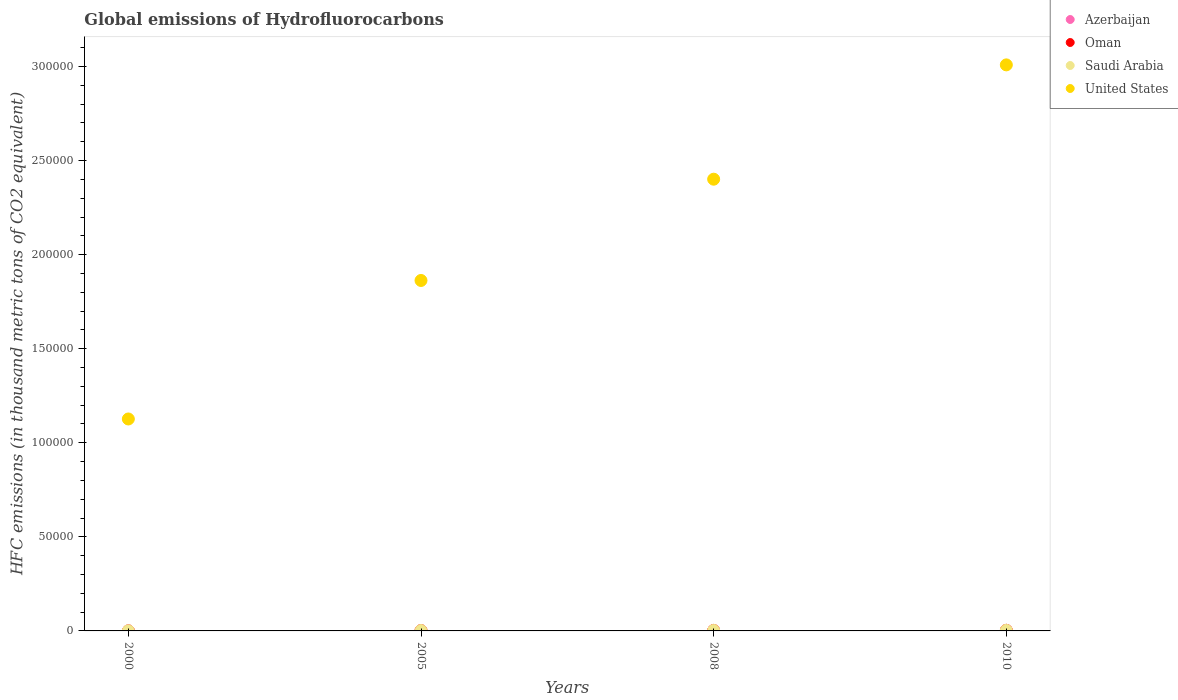How many different coloured dotlines are there?
Your response must be concise. 4. Is the number of dotlines equal to the number of legend labels?
Your answer should be very brief. Yes. What is the global emissions of Hydrofluorocarbons in Saudi Arabia in 2010?
Provide a succinct answer. 316. Across all years, what is the maximum global emissions of Hydrofluorocarbons in United States?
Offer a terse response. 3.01e+05. In which year was the global emissions of Hydrofluorocarbons in Oman maximum?
Your answer should be very brief. 2010. What is the total global emissions of Hydrofluorocarbons in Oman in the graph?
Provide a succinct answer. 781.1. What is the difference between the global emissions of Hydrofluorocarbons in United States in 2005 and that in 2010?
Your response must be concise. -1.15e+05. What is the difference between the global emissions of Hydrofluorocarbons in Oman in 2000 and the global emissions of Hydrofluorocarbons in Saudi Arabia in 2010?
Provide a succinct answer. -307.4. What is the average global emissions of Hydrofluorocarbons in Oman per year?
Your response must be concise. 195.27. In the year 2010, what is the difference between the global emissions of Hydrofluorocarbons in Saudi Arabia and global emissions of Hydrofluorocarbons in Azerbaijan?
Offer a terse response. 230. What is the ratio of the global emissions of Hydrofluorocarbons in Saudi Arabia in 2000 to that in 2010?
Your answer should be very brief. 0.24. Is the global emissions of Hydrofluorocarbons in Oman in 2000 less than that in 2010?
Give a very brief answer. Yes. What is the difference between the highest and the second highest global emissions of Hydrofluorocarbons in Saudi Arabia?
Give a very brief answer. 49.5. What is the difference between the highest and the lowest global emissions of Hydrofluorocarbons in Saudi Arabia?
Your answer should be very brief. 240.5. Is the sum of the global emissions of Hydrofluorocarbons in Oman in 2008 and 2010 greater than the maximum global emissions of Hydrofluorocarbons in United States across all years?
Make the answer very short. No. Is it the case that in every year, the sum of the global emissions of Hydrofluorocarbons in Oman and global emissions of Hydrofluorocarbons in Saudi Arabia  is greater than the sum of global emissions of Hydrofluorocarbons in Azerbaijan and global emissions of Hydrofluorocarbons in United States?
Provide a succinct answer. Yes. Is it the case that in every year, the sum of the global emissions of Hydrofluorocarbons in United States and global emissions of Hydrofluorocarbons in Saudi Arabia  is greater than the global emissions of Hydrofluorocarbons in Azerbaijan?
Give a very brief answer. Yes. What is the difference between two consecutive major ticks on the Y-axis?
Your response must be concise. 5.00e+04. Are the values on the major ticks of Y-axis written in scientific E-notation?
Your response must be concise. No. Does the graph contain grids?
Keep it short and to the point. No. Where does the legend appear in the graph?
Make the answer very short. Top right. How are the legend labels stacked?
Ensure brevity in your answer.  Vertical. What is the title of the graph?
Offer a very short reply. Global emissions of Hydrofluorocarbons. Does "East Asia (developing only)" appear as one of the legend labels in the graph?
Provide a succinct answer. No. What is the label or title of the Y-axis?
Your response must be concise. HFC emissions (in thousand metric tons of CO2 equivalent). What is the HFC emissions (in thousand metric tons of CO2 equivalent) of Oman in 2000?
Your answer should be very brief. 8.6. What is the HFC emissions (in thousand metric tons of CO2 equivalent) in Saudi Arabia in 2000?
Keep it short and to the point. 75.5. What is the HFC emissions (in thousand metric tons of CO2 equivalent) in United States in 2000?
Give a very brief answer. 1.13e+05. What is the HFC emissions (in thousand metric tons of CO2 equivalent) of Azerbaijan in 2005?
Offer a terse response. 55.4. What is the HFC emissions (in thousand metric tons of CO2 equivalent) of Oman in 2005?
Your answer should be compact. 173.6. What is the HFC emissions (in thousand metric tons of CO2 equivalent) in Saudi Arabia in 2005?
Offer a terse response. 196.9. What is the HFC emissions (in thousand metric tons of CO2 equivalent) in United States in 2005?
Your answer should be very brief. 1.86e+05. What is the HFC emissions (in thousand metric tons of CO2 equivalent) of Azerbaijan in 2008?
Make the answer very short. 73.1. What is the HFC emissions (in thousand metric tons of CO2 equivalent) of Oman in 2008?
Provide a succinct answer. 266.9. What is the HFC emissions (in thousand metric tons of CO2 equivalent) in Saudi Arabia in 2008?
Provide a succinct answer. 266.5. What is the HFC emissions (in thousand metric tons of CO2 equivalent) of United States in 2008?
Provide a succinct answer. 2.40e+05. What is the HFC emissions (in thousand metric tons of CO2 equivalent) in Azerbaijan in 2010?
Make the answer very short. 86. What is the HFC emissions (in thousand metric tons of CO2 equivalent) of Oman in 2010?
Your answer should be compact. 332. What is the HFC emissions (in thousand metric tons of CO2 equivalent) of Saudi Arabia in 2010?
Give a very brief answer. 316. What is the HFC emissions (in thousand metric tons of CO2 equivalent) in United States in 2010?
Offer a terse response. 3.01e+05. Across all years, what is the maximum HFC emissions (in thousand metric tons of CO2 equivalent) of Azerbaijan?
Provide a short and direct response. 86. Across all years, what is the maximum HFC emissions (in thousand metric tons of CO2 equivalent) in Oman?
Your answer should be very brief. 332. Across all years, what is the maximum HFC emissions (in thousand metric tons of CO2 equivalent) of Saudi Arabia?
Provide a short and direct response. 316. Across all years, what is the maximum HFC emissions (in thousand metric tons of CO2 equivalent) in United States?
Make the answer very short. 3.01e+05. Across all years, what is the minimum HFC emissions (in thousand metric tons of CO2 equivalent) of Oman?
Offer a terse response. 8.6. Across all years, what is the minimum HFC emissions (in thousand metric tons of CO2 equivalent) of Saudi Arabia?
Your answer should be compact. 75.5. Across all years, what is the minimum HFC emissions (in thousand metric tons of CO2 equivalent) of United States?
Offer a terse response. 1.13e+05. What is the total HFC emissions (in thousand metric tons of CO2 equivalent) in Azerbaijan in the graph?
Make the answer very short. 223. What is the total HFC emissions (in thousand metric tons of CO2 equivalent) of Oman in the graph?
Offer a very short reply. 781.1. What is the total HFC emissions (in thousand metric tons of CO2 equivalent) of Saudi Arabia in the graph?
Your answer should be very brief. 854.9. What is the total HFC emissions (in thousand metric tons of CO2 equivalent) of United States in the graph?
Provide a succinct answer. 8.40e+05. What is the difference between the HFC emissions (in thousand metric tons of CO2 equivalent) in Azerbaijan in 2000 and that in 2005?
Keep it short and to the point. -46.9. What is the difference between the HFC emissions (in thousand metric tons of CO2 equivalent) in Oman in 2000 and that in 2005?
Keep it short and to the point. -165. What is the difference between the HFC emissions (in thousand metric tons of CO2 equivalent) in Saudi Arabia in 2000 and that in 2005?
Offer a terse response. -121.4. What is the difference between the HFC emissions (in thousand metric tons of CO2 equivalent) of United States in 2000 and that in 2005?
Your response must be concise. -7.36e+04. What is the difference between the HFC emissions (in thousand metric tons of CO2 equivalent) of Azerbaijan in 2000 and that in 2008?
Offer a terse response. -64.6. What is the difference between the HFC emissions (in thousand metric tons of CO2 equivalent) of Oman in 2000 and that in 2008?
Provide a short and direct response. -258.3. What is the difference between the HFC emissions (in thousand metric tons of CO2 equivalent) in Saudi Arabia in 2000 and that in 2008?
Your response must be concise. -191. What is the difference between the HFC emissions (in thousand metric tons of CO2 equivalent) of United States in 2000 and that in 2008?
Your answer should be very brief. -1.27e+05. What is the difference between the HFC emissions (in thousand metric tons of CO2 equivalent) of Azerbaijan in 2000 and that in 2010?
Provide a succinct answer. -77.5. What is the difference between the HFC emissions (in thousand metric tons of CO2 equivalent) in Oman in 2000 and that in 2010?
Provide a succinct answer. -323.4. What is the difference between the HFC emissions (in thousand metric tons of CO2 equivalent) of Saudi Arabia in 2000 and that in 2010?
Make the answer very short. -240.5. What is the difference between the HFC emissions (in thousand metric tons of CO2 equivalent) in United States in 2000 and that in 2010?
Your answer should be very brief. -1.88e+05. What is the difference between the HFC emissions (in thousand metric tons of CO2 equivalent) in Azerbaijan in 2005 and that in 2008?
Offer a very short reply. -17.7. What is the difference between the HFC emissions (in thousand metric tons of CO2 equivalent) of Oman in 2005 and that in 2008?
Offer a very short reply. -93.3. What is the difference between the HFC emissions (in thousand metric tons of CO2 equivalent) of Saudi Arabia in 2005 and that in 2008?
Your answer should be compact. -69.6. What is the difference between the HFC emissions (in thousand metric tons of CO2 equivalent) of United States in 2005 and that in 2008?
Your response must be concise. -5.38e+04. What is the difference between the HFC emissions (in thousand metric tons of CO2 equivalent) of Azerbaijan in 2005 and that in 2010?
Offer a very short reply. -30.6. What is the difference between the HFC emissions (in thousand metric tons of CO2 equivalent) in Oman in 2005 and that in 2010?
Your answer should be very brief. -158.4. What is the difference between the HFC emissions (in thousand metric tons of CO2 equivalent) in Saudi Arabia in 2005 and that in 2010?
Provide a short and direct response. -119.1. What is the difference between the HFC emissions (in thousand metric tons of CO2 equivalent) in United States in 2005 and that in 2010?
Keep it short and to the point. -1.15e+05. What is the difference between the HFC emissions (in thousand metric tons of CO2 equivalent) of Oman in 2008 and that in 2010?
Keep it short and to the point. -65.1. What is the difference between the HFC emissions (in thousand metric tons of CO2 equivalent) of Saudi Arabia in 2008 and that in 2010?
Your answer should be compact. -49.5. What is the difference between the HFC emissions (in thousand metric tons of CO2 equivalent) in United States in 2008 and that in 2010?
Your answer should be very brief. -6.08e+04. What is the difference between the HFC emissions (in thousand metric tons of CO2 equivalent) in Azerbaijan in 2000 and the HFC emissions (in thousand metric tons of CO2 equivalent) in Oman in 2005?
Make the answer very short. -165.1. What is the difference between the HFC emissions (in thousand metric tons of CO2 equivalent) of Azerbaijan in 2000 and the HFC emissions (in thousand metric tons of CO2 equivalent) of Saudi Arabia in 2005?
Provide a succinct answer. -188.4. What is the difference between the HFC emissions (in thousand metric tons of CO2 equivalent) of Azerbaijan in 2000 and the HFC emissions (in thousand metric tons of CO2 equivalent) of United States in 2005?
Give a very brief answer. -1.86e+05. What is the difference between the HFC emissions (in thousand metric tons of CO2 equivalent) in Oman in 2000 and the HFC emissions (in thousand metric tons of CO2 equivalent) in Saudi Arabia in 2005?
Offer a terse response. -188.3. What is the difference between the HFC emissions (in thousand metric tons of CO2 equivalent) in Oman in 2000 and the HFC emissions (in thousand metric tons of CO2 equivalent) in United States in 2005?
Make the answer very short. -1.86e+05. What is the difference between the HFC emissions (in thousand metric tons of CO2 equivalent) of Saudi Arabia in 2000 and the HFC emissions (in thousand metric tons of CO2 equivalent) of United States in 2005?
Offer a very short reply. -1.86e+05. What is the difference between the HFC emissions (in thousand metric tons of CO2 equivalent) in Azerbaijan in 2000 and the HFC emissions (in thousand metric tons of CO2 equivalent) in Oman in 2008?
Your answer should be very brief. -258.4. What is the difference between the HFC emissions (in thousand metric tons of CO2 equivalent) in Azerbaijan in 2000 and the HFC emissions (in thousand metric tons of CO2 equivalent) in Saudi Arabia in 2008?
Your answer should be very brief. -258. What is the difference between the HFC emissions (in thousand metric tons of CO2 equivalent) in Azerbaijan in 2000 and the HFC emissions (in thousand metric tons of CO2 equivalent) in United States in 2008?
Provide a short and direct response. -2.40e+05. What is the difference between the HFC emissions (in thousand metric tons of CO2 equivalent) in Oman in 2000 and the HFC emissions (in thousand metric tons of CO2 equivalent) in Saudi Arabia in 2008?
Keep it short and to the point. -257.9. What is the difference between the HFC emissions (in thousand metric tons of CO2 equivalent) of Oman in 2000 and the HFC emissions (in thousand metric tons of CO2 equivalent) of United States in 2008?
Make the answer very short. -2.40e+05. What is the difference between the HFC emissions (in thousand metric tons of CO2 equivalent) of Saudi Arabia in 2000 and the HFC emissions (in thousand metric tons of CO2 equivalent) of United States in 2008?
Provide a short and direct response. -2.40e+05. What is the difference between the HFC emissions (in thousand metric tons of CO2 equivalent) of Azerbaijan in 2000 and the HFC emissions (in thousand metric tons of CO2 equivalent) of Oman in 2010?
Give a very brief answer. -323.5. What is the difference between the HFC emissions (in thousand metric tons of CO2 equivalent) in Azerbaijan in 2000 and the HFC emissions (in thousand metric tons of CO2 equivalent) in Saudi Arabia in 2010?
Keep it short and to the point. -307.5. What is the difference between the HFC emissions (in thousand metric tons of CO2 equivalent) in Azerbaijan in 2000 and the HFC emissions (in thousand metric tons of CO2 equivalent) in United States in 2010?
Your answer should be very brief. -3.01e+05. What is the difference between the HFC emissions (in thousand metric tons of CO2 equivalent) in Oman in 2000 and the HFC emissions (in thousand metric tons of CO2 equivalent) in Saudi Arabia in 2010?
Offer a very short reply. -307.4. What is the difference between the HFC emissions (in thousand metric tons of CO2 equivalent) of Oman in 2000 and the HFC emissions (in thousand metric tons of CO2 equivalent) of United States in 2010?
Give a very brief answer. -3.01e+05. What is the difference between the HFC emissions (in thousand metric tons of CO2 equivalent) in Saudi Arabia in 2000 and the HFC emissions (in thousand metric tons of CO2 equivalent) in United States in 2010?
Provide a succinct answer. -3.01e+05. What is the difference between the HFC emissions (in thousand metric tons of CO2 equivalent) in Azerbaijan in 2005 and the HFC emissions (in thousand metric tons of CO2 equivalent) in Oman in 2008?
Ensure brevity in your answer.  -211.5. What is the difference between the HFC emissions (in thousand metric tons of CO2 equivalent) of Azerbaijan in 2005 and the HFC emissions (in thousand metric tons of CO2 equivalent) of Saudi Arabia in 2008?
Keep it short and to the point. -211.1. What is the difference between the HFC emissions (in thousand metric tons of CO2 equivalent) of Azerbaijan in 2005 and the HFC emissions (in thousand metric tons of CO2 equivalent) of United States in 2008?
Offer a terse response. -2.40e+05. What is the difference between the HFC emissions (in thousand metric tons of CO2 equivalent) of Oman in 2005 and the HFC emissions (in thousand metric tons of CO2 equivalent) of Saudi Arabia in 2008?
Provide a short and direct response. -92.9. What is the difference between the HFC emissions (in thousand metric tons of CO2 equivalent) in Oman in 2005 and the HFC emissions (in thousand metric tons of CO2 equivalent) in United States in 2008?
Provide a succinct answer. -2.40e+05. What is the difference between the HFC emissions (in thousand metric tons of CO2 equivalent) in Saudi Arabia in 2005 and the HFC emissions (in thousand metric tons of CO2 equivalent) in United States in 2008?
Your answer should be very brief. -2.40e+05. What is the difference between the HFC emissions (in thousand metric tons of CO2 equivalent) of Azerbaijan in 2005 and the HFC emissions (in thousand metric tons of CO2 equivalent) of Oman in 2010?
Ensure brevity in your answer.  -276.6. What is the difference between the HFC emissions (in thousand metric tons of CO2 equivalent) of Azerbaijan in 2005 and the HFC emissions (in thousand metric tons of CO2 equivalent) of Saudi Arabia in 2010?
Ensure brevity in your answer.  -260.6. What is the difference between the HFC emissions (in thousand metric tons of CO2 equivalent) of Azerbaijan in 2005 and the HFC emissions (in thousand metric tons of CO2 equivalent) of United States in 2010?
Your answer should be very brief. -3.01e+05. What is the difference between the HFC emissions (in thousand metric tons of CO2 equivalent) in Oman in 2005 and the HFC emissions (in thousand metric tons of CO2 equivalent) in Saudi Arabia in 2010?
Keep it short and to the point. -142.4. What is the difference between the HFC emissions (in thousand metric tons of CO2 equivalent) of Oman in 2005 and the HFC emissions (in thousand metric tons of CO2 equivalent) of United States in 2010?
Keep it short and to the point. -3.01e+05. What is the difference between the HFC emissions (in thousand metric tons of CO2 equivalent) in Saudi Arabia in 2005 and the HFC emissions (in thousand metric tons of CO2 equivalent) in United States in 2010?
Provide a succinct answer. -3.01e+05. What is the difference between the HFC emissions (in thousand metric tons of CO2 equivalent) of Azerbaijan in 2008 and the HFC emissions (in thousand metric tons of CO2 equivalent) of Oman in 2010?
Make the answer very short. -258.9. What is the difference between the HFC emissions (in thousand metric tons of CO2 equivalent) of Azerbaijan in 2008 and the HFC emissions (in thousand metric tons of CO2 equivalent) of Saudi Arabia in 2010?
Your answer should be compact. -242.9. What is the difference between the HFC emissions (in thousand metric tons of CO2 equivalent) in Azerbaijan in 2008 and the HFC emissions (in thousand metric tons of CO2 equivalent) in United States in 2010?
Make the answer very short. -3.01e+05. What is the difference between the HFC emissions (in thousand metric tons of CO2 equivalent) of Oman in 2008 and the HFC emissions (in thousand metric tons of CO2 equivalent) of Saudi Arabia in 2010?
Your answer should be very brief. -49.1. What is the difference between the HFC emissions (in thousand metric tons of CO2 equivalent) in Oman in 2008 and the HFC emissions (in thousand metric tons of CO2 equivalent) in United States in 2010?
Ensure brevity in your answer.  -3.01e+05. What is the difference between the HFC emissions (in thousand metric tons of CO2 equivalent) of Saudi Arabia in 2008 and the HFC emissions (in thousand metric tons of CO2 equivalent) of United States in 2010?
Make the answer very short. -3.01e+05. What is the average HFC emissions (in thousand metric tons of CO2 equivalent) in Azerbaijan per year?
Make the answer very short. 55.75. What is the average HFC emissions (in thousand metric tons of CO2 equivalent) of Oman per year?
Give a very brief answer. 195.28. What is the average HFC emissions (in thousand metric tons of CO2 equivalent) in Saudi Arabia per year?
Give a very brief answer. 213.72. What is the average HFC emissions (in thousand metric tons of CO2 equivalent) of United States per year?
Offer a terse response. 2.10e+05. In the year 2000, what is the difference between the HFC emissions (in thousand metric tons of CO2 equivalent) of Azerbaijan and HFC emissions (in thousand metric tons of CO2 equivalent) of Oman?
Your answer should be very brief. -0.1. In the year 2000, what is the difference between the HFC emissions (in thousand metric tons of CO2 equivalent) in Azerbaijan and HFC emissions (in thousand metric tons of CO2 equivalent) in Saudi Arabia?
Your answer should be compact. -67. In the year 2000, what is the difference between the HFC emissions (in thousand metric tons of CO2 equivalent) in Azerbaijan and HFC emissions (in thousand metric tons of CO2 equivalent) in United States?
Offer a terse response. -1.13e+05. In the year 2000, what is the difference between the HFC emissions (in thousand metric tons of CO2 equivalent) in Oman and HFC emissions (in thousand metric tons of CO2 equivalent) in Saudi Arabia?
Your response must be concise. -66.9. In the year 2000, what is the difference between the HFC emissions (in thousand metric tons of CO2 equivalent) in Oman and HFC emissions (in thousand metric tons of CO2 equivalent) in United States?
Ensure brevity in your answer.  -1.13e+05. In the year 2000, what is the difference between the HFC emissions (in thousand metric tons of CO2 equivalent) of Saudi Arabia and HFC emissions (in thousand metric tons of CO2 equivalent) of United States?
Offer a terse response. -1.13e+05. In the year 2005, what is the difference between the HFC emissions (in thousand metric tons of CO2 equivalent) of Azerbaijan and HFC emissions (in thousand metric tons of CO2 equivalent) of Oman?
Provide a succinct answer. -118.2. In the year 2005, what is the difference between the HFC emissions (in thousand metric tons of CO2 equivalent) of Azerbaijan and HFC emissions (in thousand metric tons of CO2 equivalent) of Saudi Arabia?
Your response must be concise. -141.5. In the year 2005, what is the difference between the HFC emissions (in thousand metric tons of CO2 equivalent) of Azerbaijan and HFC emissions (in thousand metric tons of CO2 equivalent) of United States?
Your answer should be compact. -1.86e+05. In the year 2005, what is the difference between the HFC emissions (in thousand metric tons of CO2 equivalent) of Oman and HFC emissions (in thousand metric tons of CO2 equivalent) of Saudi Arabia?
Provide a short and direct response. -23.3. In the year 2005, what is the difference between the HFC emissions (in thousand metric tons of CO2 equivalent) of Oman and HFC emissions (in thousand metric tons of CO2 equivalent) of United States?
Provide a succinct answer. -1.86e+05. In the year 2005, what is the difference between the HFC emissions (in thousand metric tons of CO2 equivalent) of Saudi Arabia and HFC emissions (in thousand metric tons of CO2 equivalent) of United States?
Provide a short and direct response. -1.86e+05. In the year 2008, what is the difference between the HFC emissions (in thousand metric tons of CO2 equivalent) in Azerbaijan and HFC emissions (in thousand metric tons of CO2 equivalent) in Oman?
Offer a terse response. -193.8. In the year 2008, what is the difference between the HFC emissions (in thousand metric tons of CO2 equivalent) of Azerbaijan and HFC emissions (in thousand metric tons of CO2 equivalent) of Saudi Arabia?
Your answer should be very brief. -193.4. In the year 2008, what is the difference between the HFC emissions (in thousand metric tons of CO2 equivalent) of Azerbaijan and HFC emissions (in thousand metric tons of CO2 equivalent) of United States?
Offer a terse response. -2.40e+05. In the year 2008, what is the difference between the HFC emissions (in thousand metric tons of CO2 equivalent) of Oman and HFC emissions (in thousand metric tons of CO2 equivalent) of United States?
Provide a succinct answer. -2.40e+05. In the year 2008, what is the difference between the HFC emissions (in thousand metric tons of CO2 equivalent) in Saudi Arabia and HFC emissions (in thousand metric tons of CO2 equivalent) in United States?
Give a very brief answer. -2.40e+05. In the year 2010, what is the difference between the HFC emissions (in thousand metric tons of CO2 equivalent) in Azerbaijan and HFC emissions (in thousand metric tons of CO2 equivalent) in Oman?
Ensure brevity in your answer.  -246. In the year 2010, what is the difference between the HFC emissions (in thousand metric tons of CO2 equivalent) of Azerbaijan and HFC emissions (in thousand metric tons of CO2 equivalent) of Saudi Arabia?
Make the answer very short. -230. In the year 2010, what is the difference between the HFC emissions (in thousand metric tons of CO2 equivalent) of Azerbaijan and HFC emissions (in thousand metric tons of CO2 equivalent) of United States?
Provide a short and direct response. -3.01e+05. In the year 2010, what is the difference between the HFC emissions (in thousand metric tons of CO2 equivalent) in Oman and HFC emissions (in thousand metric tons of CO2 equivalent) in Saudi Arabia?
Your answer should be compact. 16. In the year 2010, what is the difference between the HFC emissions (in thousand metric tons of CO2 equivalent) in Oman and HFC emissions (in thousand metric tons of CO2 equivalent) in United States?
Your response must be concise. -3.01e+05. In the year 2010, what is the difference between the HFC emissions (in thousand metric tons of CO2 equivalent) of Saudi Arabia and HFC emissions (in thousand metric tons of CO2 equivalent) of United States?
Make the answer very short. -3.01e+05. What is the ratio of the HFC emissions (in thousand metric tons of CO2 equivalent) in Azerbaijan in 2000 to that in 2005?
Offer a terse response. 0.15. What is the ratio of the HFC emissions (in thousand metric tons of CO2 equivalent) in Oman in 2000 to that in 2005?
Your answer should be very brief. 0.05. What is the ratio of the HFC emissions (in thousand metric tons of CO2 equivalent) of Saudi Arabia in 2000 to that in 2005?
Your answer should be very brief. 0.38. What is the ratio of the HFC emissions (in thousand metric tons of CO2 equivalent) in United States in 2000 to that in 2005?
Provide a short and direct response. 0.6. What is the ratio of the HFC emissions (in thousand metric tons of CO2 equivalent) of Azerbaijan in 2000 to that in 2008?
Provide a short and direct response. 0.12. What is the ratio of the HFC emissions (in thousand metric tons of CO2 equivalent) of Oman in 2000 to that in 2008?
Your answer should be compact. 0.03. What is the ratio of the HFC emissions (in thousand metric tons of CO2 equivalent) in Saudi Arabia in 2000 to that in 2008?
Your answer should be compact. 0.28. What is the ratio of the HFC emissions (in thousand metric tons of CO2 equivalent) in United States in 2000 to that in 2008?
Your response must be concise. 0.47. What is the ratio of the HFC emissions (in thousand metric tons of CO2 equivalent) of Azerbaijan in 2000 to that in 2010?
Ensure brevity in your answer.  0.1. What is the ratio of the HFC emissions (in thousand metric tons of CO2 equivalent) in Oman in 2000 to that in 2010?
Offer a terse response. 0.03. What is the ratio of the HFC emissions (in thousand metric tons of CO2 equivalent) in Saudi Arabia in 2000 to that in 2010?
Your response must be concise. 0.24. What is the ratio of the HFC emissions (in thousand metric tons of CO2 equivalent) of United States in 2000 to that in 2010?
Your answer should be compact. 0.37. What is the ratio of the HFC emissions (in thousand metric tons of CO2 equivalent) of Azerbaijan in 2005 to that in 2008?
Your response must be concise. 0.76. What is the ratio of the HFC emissions (in thousand metric tons of CO2 equivalent) of Oman in 2005 to that in 2008?
Your answer should be compact. 0.65. What is the ratio of the HFC emissions (in thousand metric tons of CO2 equivalent) in Saudi Arabia in 2005 to that in 2008?
Your answer should be very brief. 0.74. What is the ratio of the HFC emissions (in thousand metric tons of CO2 equivalent) in United States in 2005 to that in 2008?
Make the answer very short. 0.78. What is the ratio of the HFC emissions (in thousand metric tons of CO2 equivalent) in Azerbaijan in 2005 to that in 2010?
Keep it short and to the point. 0.64. What is the ratio of the HFC emissions (in thousand metric tons of CO2 equivalent) of Oman in 2005 to that in 2010?
Ensure brevity in your answer.  0.52. What is the ratio of the HFC emissions (in thousand metric tons of CO2 equivalent) in Saudi Arabia in 2005 to that in 2010?
Offer a very short reply. 0.62. What is the ratio of the HFC emissions (in thousand metric tons of CO2 equivalent) in United States in 2005 to that in 2010?
Provide a succinct answer. 0.62. What is the ratio of the HFC emissions (in thousand metric tons of CO2 equivalent) in Azerbaijan in 2008 to that in 2010?
Your response must be concise. 0.85. What is the ratio of the HFC emissions (in thousand metric tons of CO2 equivalent) in Oman in 2008 to that in 2010?
Offer a very short reply. 0.8. What is the ratio of the HFC emissions (in thousand metric tons of CO2 equivalent) in Saudi Arabia in 2008 to that in 2010?
Keep it short and to the point. 0.84. What is the ratio of the HFC emissions (in thousand metric tons of CO2 equivalent) in United States in 2008 to that in 2010?
Your answer should be very brief. 0.8. What is the difference between the highest and the second highest HFC emissions (in thousand metric tons of CO2 equivalent) of Oman?
Keep it short and to the point. 65.1. What is the difference between the highest and the second highest HFC emissions (in thousand metric tons of CO2 equivalent) in Saudi Arabia?
Offer a very short reply. 49.5. What is the difference between the highest and the second highest HFC emissions (in thousand metric tons of CO2 equivalent) in United States?
Your response must be concise. 6.08e+04. What is the difference between the highest and the lowest HFC emissions (in thousand metric tons of CO2 equivalent) of Azerbaijan?
Offer a terse response. 77.5. What is the difference between the highest and the lowest HFC emissions (in thousand metric tons of CO2 equivalent) in Oman?
Offer a very short reply. 323.4. What is the difference between the highest and the lowest HFC emissions (in thousand metric tons of CO2 equivalent) of Saudi Arabia?
Make the answer very short. 240.5. What is the difference between the highest and the lowest HFC emissions (in thousand metric tons of CO2 equivalent) in United States?
Give a very brief answer. 1.88e+05. 